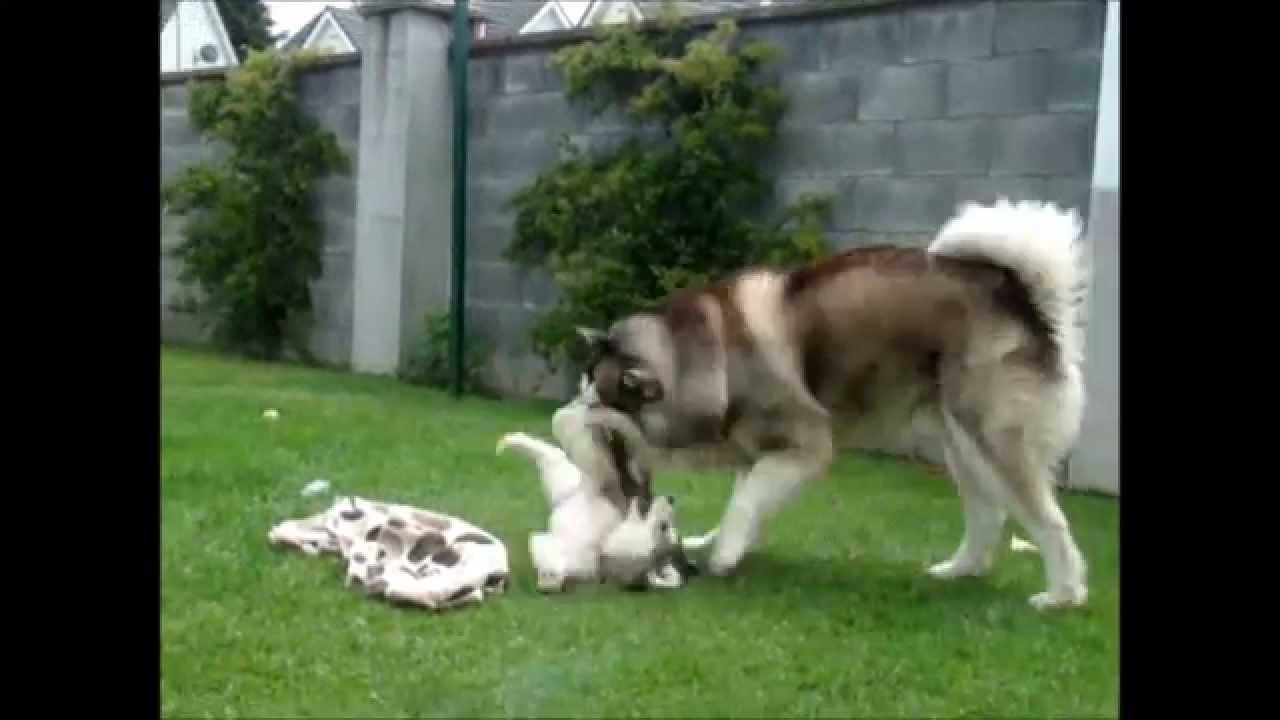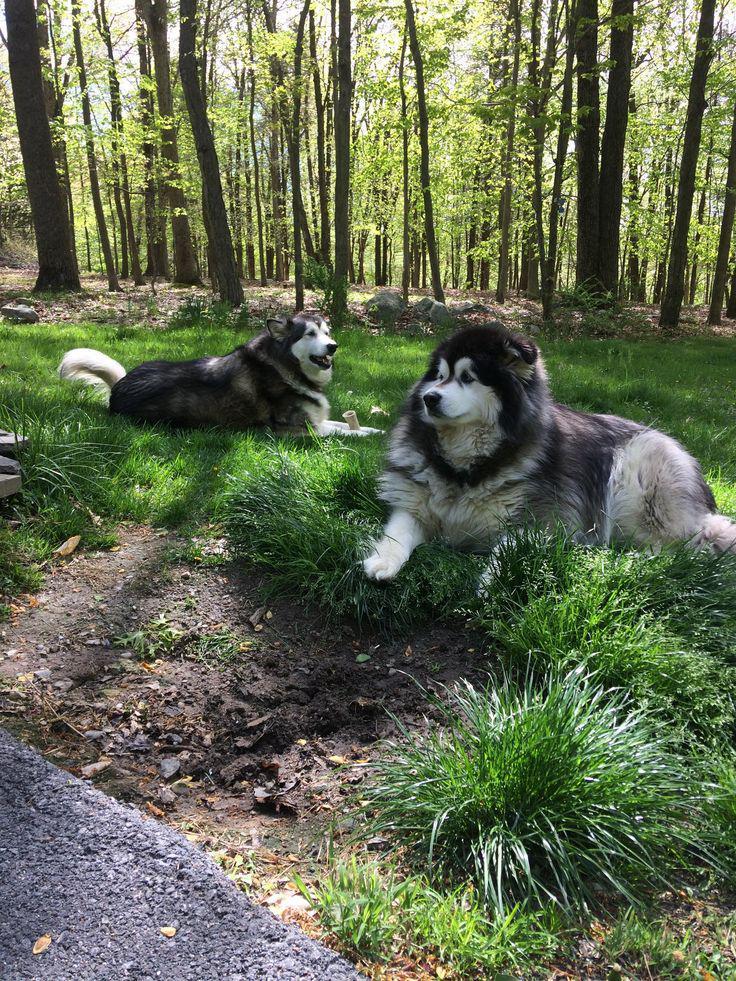The first image is the image on the left, the second image is the image on the right. Assess this claim about the two images: "No image contains more than one dog, all dogs are husky-type, and the image on the left shows a dog standing on all fours.". Correct or not? Answer yes or no. No. The first image is the image on the left, the second image is the image on the right. Evaluate the accuracy of this statement regarding the images: "There are only two dogs.". Is it true? Answer yes or no. No. 